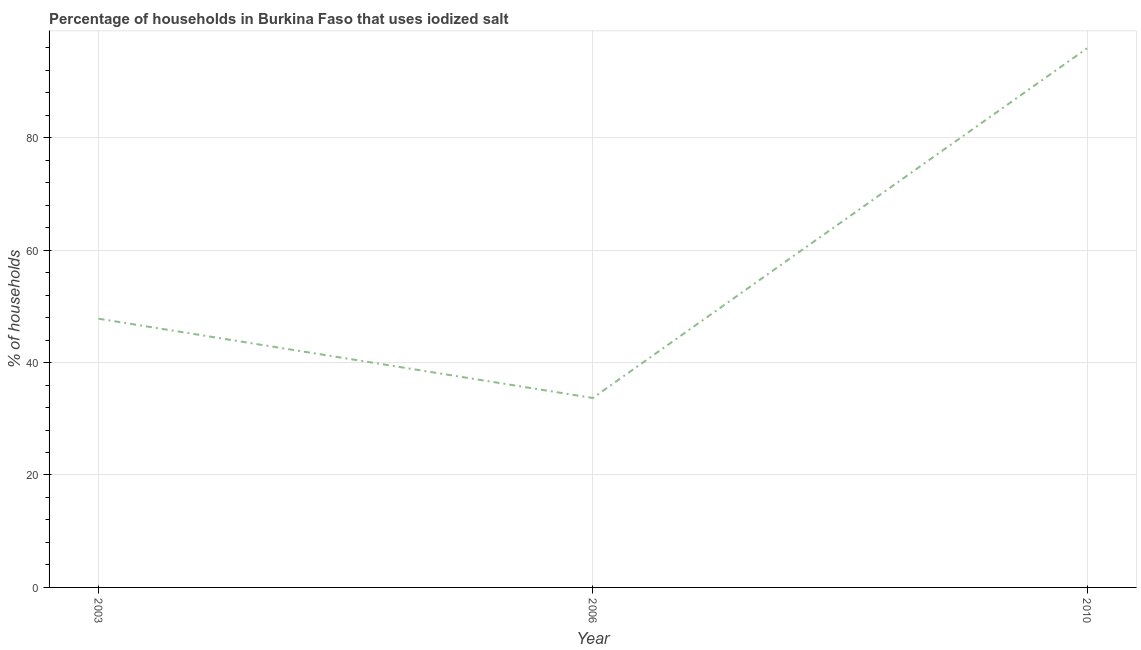What is the percentage of households where iodized salt is consumed in 2006?
Your answer should be compact. 33.7. Across all years, what is the maximum percentage of households where iodized salt is consumed?
Provide a short and direct response. 95.9. Across all years, what is the minimum percentage of households where iodized salt is consumed?
Your answer should be compact. 33.7. In which year was the percentage of households where iodized salt is consumed minimum?
Give a very brief answer. 2006. What is the sum of the percentage of households where iodized salt is consumed?
Offer a very short reply. 177.4. What is the difference between the percentage of households where iodized salt is consumed in 2003 and 2006?
Offer a terse response. 14.1. What is the average percentage of households where iodized salt is consumed per year?
Your answer should be compact. 59.13. What is the median percentage of households where iodized salt is consumed?
Offer a terse response. 47.8. What is the ratio of the percentage of households where iodized salt is consumed in 2003 to that in 2006?
Your response must be concise. 1.42. Is the difference between the percentage of households where iodized salt is consumed in 2003 and 2006 greater than the difference between any two years?
Offer a very short reply. No. What is the difference between the highest and the second highest percentage of households where iodized salt is consumed?
Offer a terse response. 48.1. Is the sum of the percentage of households where iodized salt is consumed in 2003 and 2010 greater than the maximum percentage of households where iodized salt is consumed across all years?
Offer a very short reply. Yes. What is the difference between the highest and the lowest percentage of households where iodized salt is consumed?
Your answer should be very brief. 62.2. In how many years, is the percentage of households where iodized salt is consumed greater than the average percentage of households where iodized salt is consumed taken over all years?
Provide a short and direct response. 1. Does the percentage of households where iodized salt is consumed monotonically increase over the years?
Offer a very short reply. No. How many lines are there?
Provide a short and direct response. 1. How many years are there in the graph?
Offer a very short reply. 3. What is the difference between two consecutive major ticks on the Y-axis?
Ensure brevity in your answer.  20. What is the title of the graph?
Offer a terse response. Percentage of households in Burkina Faso that uses iodized salt. What is the label or title of the Y-axis?
Give a very brief answer. % of households. What is the % of households in 2003?
Your answer should be very brief. 47.8. What is the % of households of 2006?
Offer a terse response. 33.7. What is the % of households in 2010?
Offer a very short reply. 95.9. What is the difference between the % of households in 2003 and 2006?
Your response must be concise. 14.1. What is the difference between the % of households in 2003 and 2010?
Ensure brevity in your answer.  -48.1. What is the difference between the % of households in 2006 and 2010?
Keep it short and to the point. -62.2. What is the ratio of the % of households in 2003 to that in 2006?
Keep it short and to the point. 1.42. What is the ratio of the % of households in 2003 to that in 2010?
Provide a succinct answer. 0.5. What is the ratio of the % of households in 2006 to that in 2010?
Your response must be concise. 0.35. 